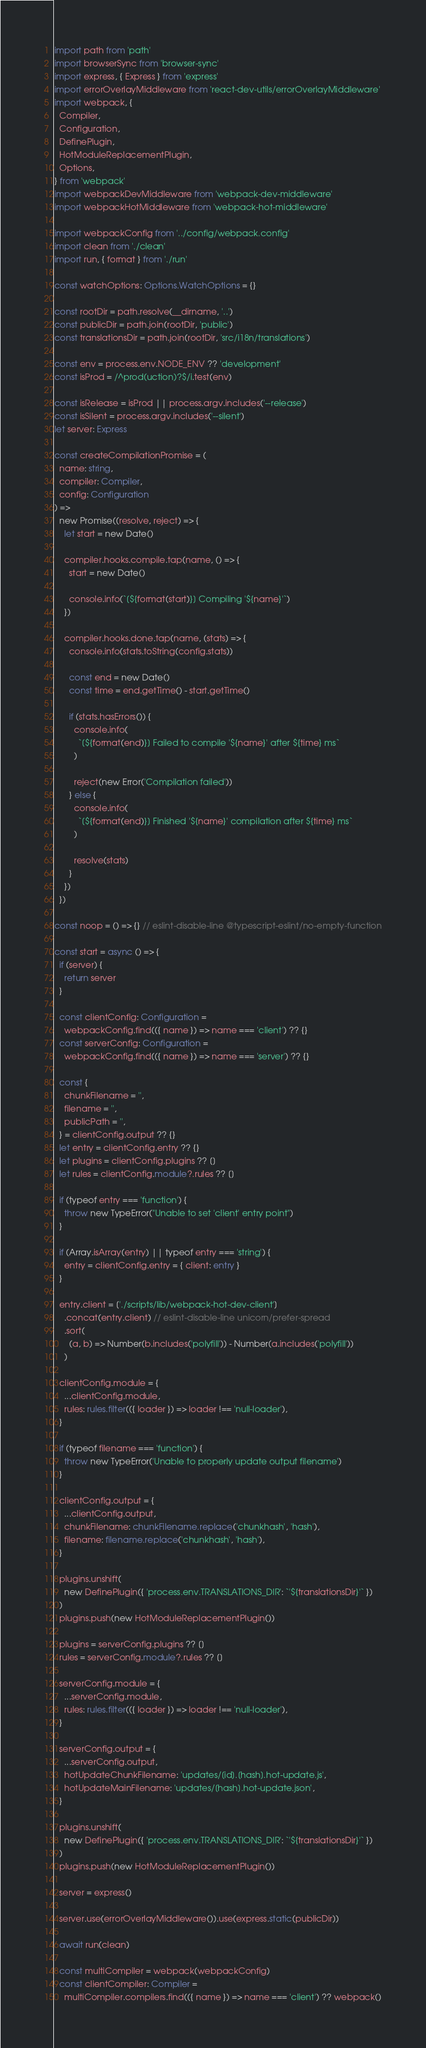Convert code to text. <code><loc_0><loc_0><loc_500><loc_500><_TypeScript_>import path from 'path'
import browserSync from 'browser-sync'
import express, { Express } from 'express'
import errorOverlayMiddleware from 'react-dev-utils/errorOverlayMiddleware'
import webpack, {
  Compiler,
  Configuration,
  DefinePlugin,
  HotModuleReplacementPlugin,
  Options,
} from 'webpack'
import webpackDevMiddleware from 'webpack-dev-middleware'
import webpackHotMiddleware from 'webpack-hot-middleware'

import webpackConfig from '../config/webpack.config'
import clean from './clean'
import run, { format } from './run'

const watchOptions: Options.WatchOptions = {}

const rootDir = path.resolve(__dirname, '..')
const publicDir = path.join(rootDir, 'public')
const translationsDir = path.join(rootDir, 'src/i18n/translations')

const env = process.env.NODE_ENV ?? 'development'
const isProd = /^prod(uction)?$/i.test(env)

const isRelease = isProd || process.argv.includes('--release')
const isSilent = process.argv.includes('--silent')
let server: Express

const createCompilationPromise = (
  name: string,
  compiler: Compiler,
  config: Configuration
) =>
  new Promise((resolve, reject) => {
    let start = new Date()

    compiler.hooks.compile.tap(name, () => {
      start = new Date()

      console.info(`[${format(start)}] Compiling '${name}'`)
    })

    compiler.hooks.done.tap(name, (stats) => {
      console.info(stats.toString(config.stats))

      const end = new Date()
      const time = end.getTime() - start.getTime()

      if (stats.hasErrors()) {
        console.info(
          `[${format(end)}] Failed to compile '${name}' after ${time} ms`
        )

        reject(new Error('Compilation failed'))
      } else {
        console.info(
          `[${format(end)}] Finished '${name}' compilation after ${time} ms`
        )

        resolve(stats)
      }
    })
  })

const noop = () => {} // eslint-disable-line @typescript-eslint/no-empty-function

const start = async () => {
  if (server) {
    return server
  }

  const clientConfig: Configuration =
    webpackConfig.find(({ name }) => name === 'client') ?? {}
  const serverConfig: Configuration =
    webpackConfig.find(({ name }) => name === 'server') ?? {}

  const {
    chunkFilename = '',
    filename = '',
    publicPath = '',
  } = clientConfig.output ?? {}
  let entry = clientConfig.entry ?? {}
  let plugins = clientConfig.plugins ?? []
  let rules = clientConfig.module?.rules ?? []

  if (typeof entry === 'function') {
    throw new TypeError("Unable to set 'client' entry point")
  }

  if (Array.isArray(entry) || typeof entry === 'string') {
    entry = clientConfig.entry = { client: entry }
  }

  entry.client = ['./scripts/lib/webpack-hot-dev-client']
    .concat(entry.client) // eslint-disable-line unicorn/prefer-spread
    .sort(
      (a, b) => Number(b.includes('polyfill')) - Number(a.includes('polyfill'))
    )

  clientConfig.module = {
    ...clientConfig.module,
    rules: rules.filter(({ loader }) => loader !== 'null-loader'),
  }

  if (typeof filename === 'function') {
    throw new TypeError('Unable to properly update output filename')
  }

  clientConfig.output = {
    ...clientConfig.output,
    chunkFilename: chunkFilename.replace('chunkhash', 'hash'),
    filename: filename.replace('chunkhash', 'hash'),
  }

  plugins.unshift(
    new DefinePlugin({ 'process.env.TRANSLATIONS_DIR': `'${translationsDir}'` })
  )
  plugins.push(new HotModuleReplacementPlugin())

  plugins = serverConfig.plugins ?? []
  rules = serverConfig.module?.rules ?? []

  serverConfig.module = {
    ...serverConfig.module,
    rules: rules.filter(({ loader }) => loader !== 'null-loader'),
  }

  serverConfig.output = {
    ...serverConfig.output,
    hotUpdateChunkFilename: 'updates/[id].[hash].hot-update.js',
    hotUpdateMainFilename: 'updates/[hash].hot-update.json',
  }

  plugins.unshift(
    new DefinePlugin({ 'process.env.TRANSLATIONS_DIR': `'${translationsDir}'` })
  )
  plugins.push(new HotModuleReplacementPlugin())

  server = express()

  server.use(errorOverlayMiddleware()).use(express.static(publicDir))

  await run(clean)

  const multiCompiler = webpack(webpackConfig)
  const clientCompiler: Compiler =
    multiCompiler.compilers.find(({ name }) => name === 'client') ?? webpack()</code> 